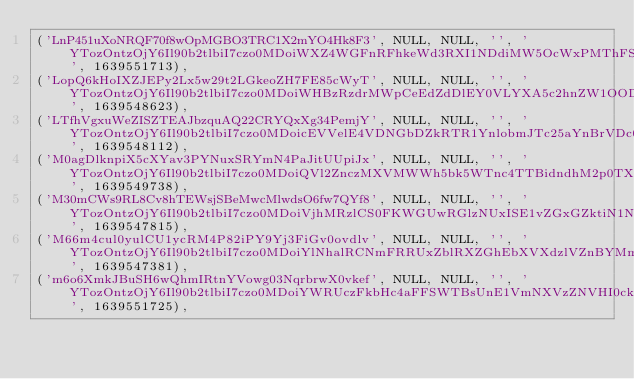<code> <loc_0><loc_0><loc_500><loc_500><_SQL_>('LnP451uXoNRQF70f8wOpMGBO3TRC1X2mYO4Hk8F3', NULL, NULL, '', 'YTozOntzOjY6Il90b2tlbiI7czo0MDoiWXZ4WGFnRFhkeWd3RXI1NDdiMW5OcWxPMThFSjZTTEd5UnJXMU1xRSI7czo5OiJfcHJldmlvdXMiO2E6MTp7czozOiJ1cmwiO3M6ODoiaHR0cDovLzoiO31zOjY6Il9mbGFzaCI7YToyOntzOjM6Im9sZCI7YTowOnt9czozOiJuZXciO2E6MDp7fX19', 1639551713),
('LopQ6kHoIXZJEPy2Lx5w29t2LGkeoZH7FE85cWyT', NULL, NULL, '', 'YTozOntzOjY6Il90b2tlbiI7czo0MDoiWHBzRzdrMWpCeEdZdDlEY0VLYXA5c2hnZW1OODczY1l2TGRVaGRpNyI7czo5OiJfcHJldmlvdXMiO2E6MTp7czozOiJ1cmwiO3M6ODoiaHR0cDovLzoiO31zOjY6Il9mbGFzaCI7YToyOntzOjM6Im9sZCI7YTowOnt9czozOiJuZXciO2E6MDp7fX19', 1639548623),
('LTfhVgxuWeZISZTEAJbzquAQ22CRYQxXg34PemjY', NULL, NULL, '', 'YTozOntzOjY6Il90b2tlbiI7czo0MDoicEVVelE4VDNGbDZkRTR1YnlobmJTc25aYnBrVDc0RlpFbDJLMHB5RyI7czo5OiJfcHJldmlvdXMiO2E6MTp7czozOiJ1cmwiO3M6ODoiaHR0cDovLzoiO31zOjY6Il9mbGFzaCI7YToyOntzOjM6Im9sZCI7YTowOnt9czozOiJuZXciO2E6MDp7fX19', 1639548112),
('M0agDlknpiX5cXYav3PYNuxSRYmN4PaJitUUpiJx', NULL, NULL, '', 'YTozOntzOjY6Il90b2tlbiI7czo0MDoiQVl2ZnczMXVMWWh5bk5WTnc4TTBidndhM2p0TXBwMldOZDZGYjJkRiI7czo5OiJfcHJldmlvdXMiO2E6MTp7czozOiJ1cmwiO3M6ODoiaHR0cDovLzoiO31zOjY6Il9mbGFzaCI7YToyOntzOjM6Im9sZCI7YTowOnt9czozOiJuZXciO2E6MDp7fX19', 1639549738),
('M30mCWs9RL8Cv8hTEWsjSBeMwcMlwdsO6fw7QYf8', NULL, NULL, '', 'YTozOntzOjY6Il90b2tlbiI7czo0MDoiVjhMRzlCS0FKWGUwRGlzNUxISE1vZGxGZktiN1NuZ0wxbmVPb3dRayI7czo5OiJfcHJldmlvdXMiO2E6MTp7czozOiJ1cmwiO3M6ODoiaHR0cDovLzoiO31zOjY6Il9mbGFzaCI7YToyOntzOjM6Im9sZCI7YTowOnt9czozOiJuZXciO2E6MDp7fX19', 1639547815),
('M66m4cul0yulCU1ycRM4P82iPY9Yj3FiGv0ovdlv', NULL, NULL, '', 'YTozOntzOjY6Il90b2tlbiI7czo0MDoiYlNhalRCNmFRRUxZblRXZGhEbXVXdzlVZnBYMmJJa0pEQjRzcUVLaiI7czo5OiJfcHJldmlvdXMiO2E6MTp7czozOiJ1cmwiO3M6ODoiaHR0cDovLzoiO31zOjY6Il9mbGFzaCI7YToyOntzOjM6Im9sZCI7YTowOnt9czozOiJuZXciO2E6MDp7fX19', 1639547381),
('m6o6XmkJBuSH6wQhmIRtnYVowg03NqrbrwX0vkef', NULL, NULL, '', 'YTozOntzOjY6Il90b2tlbiI7czo0MDoiYWRUczFkbHc4aFFSWTBsUnE1VmNXVzZNVHI0ckR2UTNyUFYwVndreiI7czo5OiJfcHJldmlvdXMiO2E6MTp7czozOiJ1cmwiO3M6ODoiaHR0cDovLzoiO31zOjY6Il9mbGFzaCI7YToyOntzOjM6Im9sZCI7YTowOnt9czozOiJuZXciO2E6MDp7fX19', 1639551725),</code> 